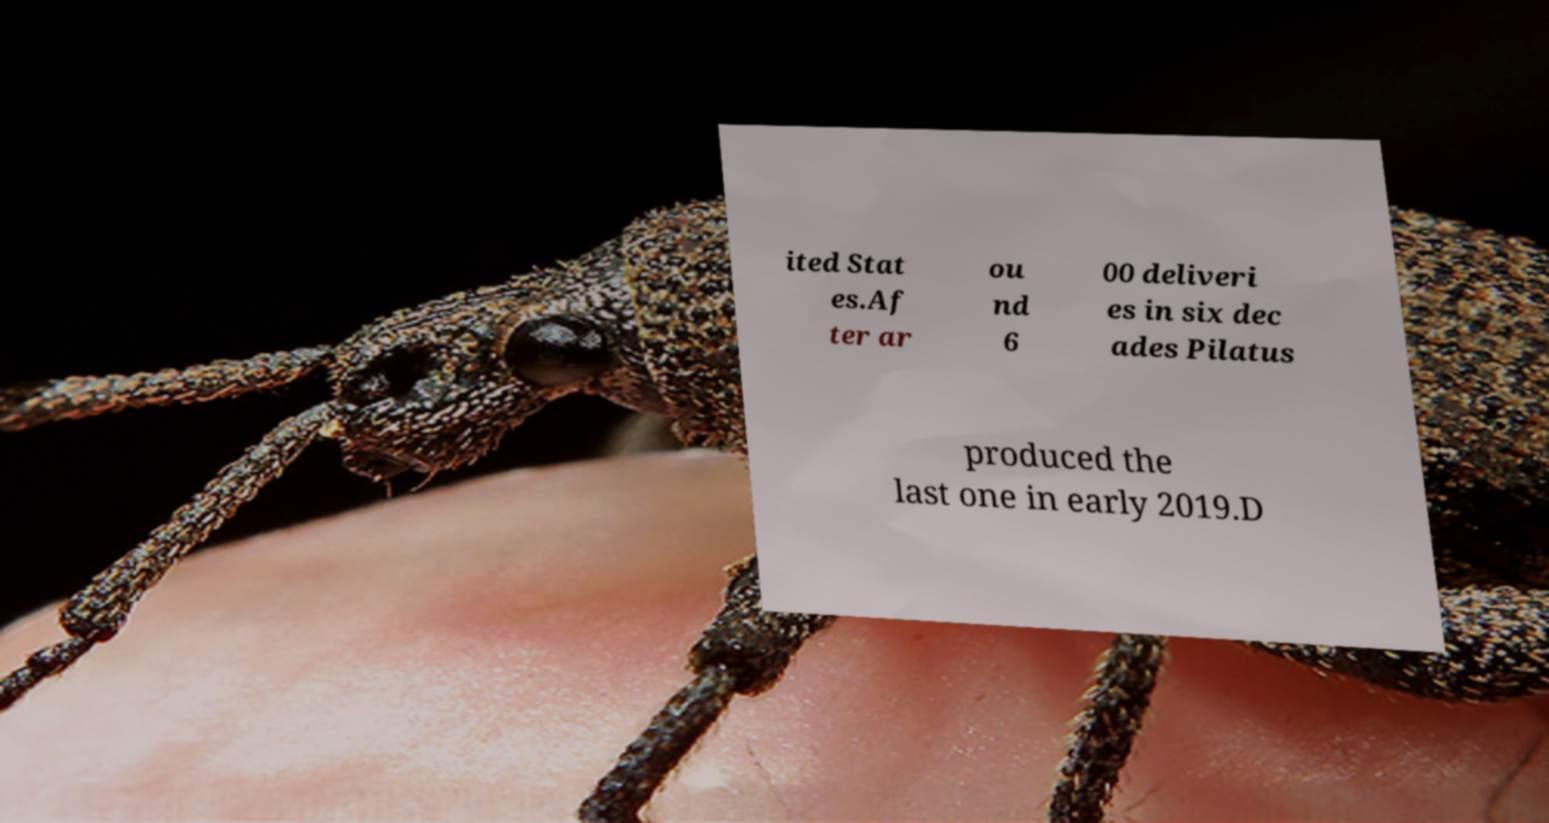There's text embedded in this image that I need extracted. Can you transcribe it verbatim? ited Stat es.Af ter ar ou nd 6 00 deliveri es in six dec ades Pilatus produced the last one in early 2019.D 